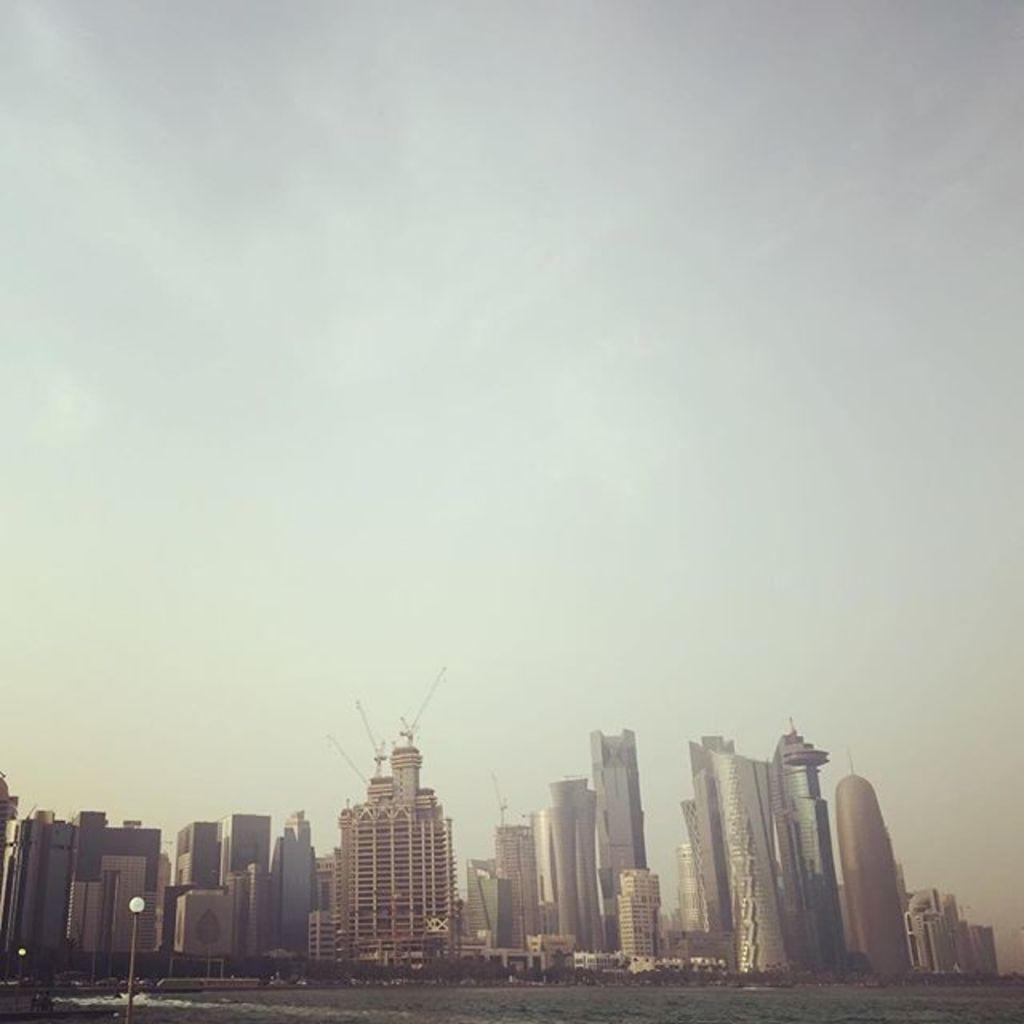Describe this image in one or two sentences. In the image we can see buildings, water, light pole and the sky. 